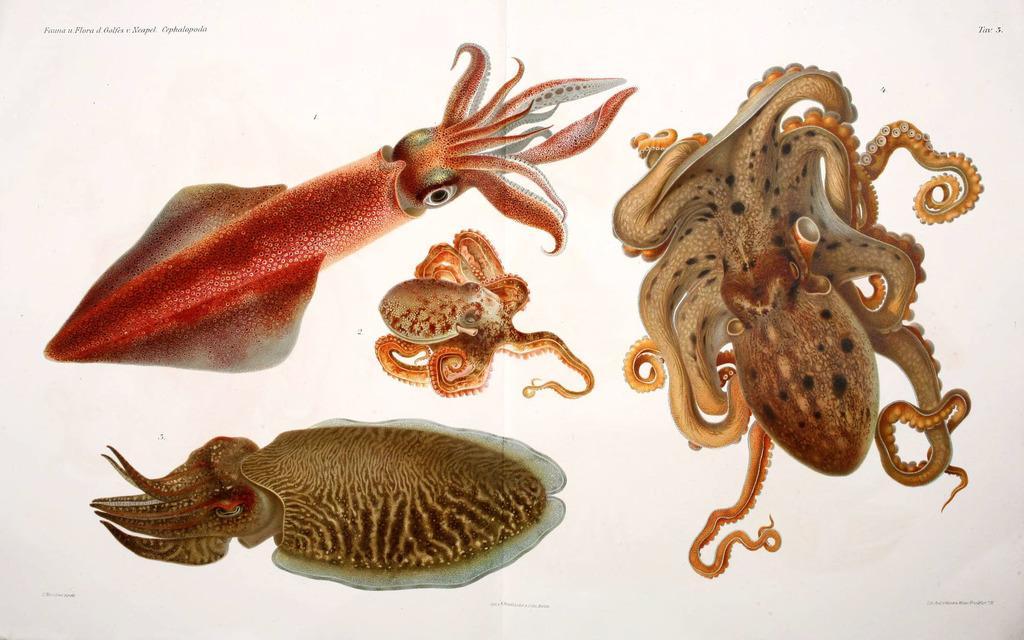Could you give a brief overview of what you see in this image? In this image we can see different types of cephalopods and some text on the image. 